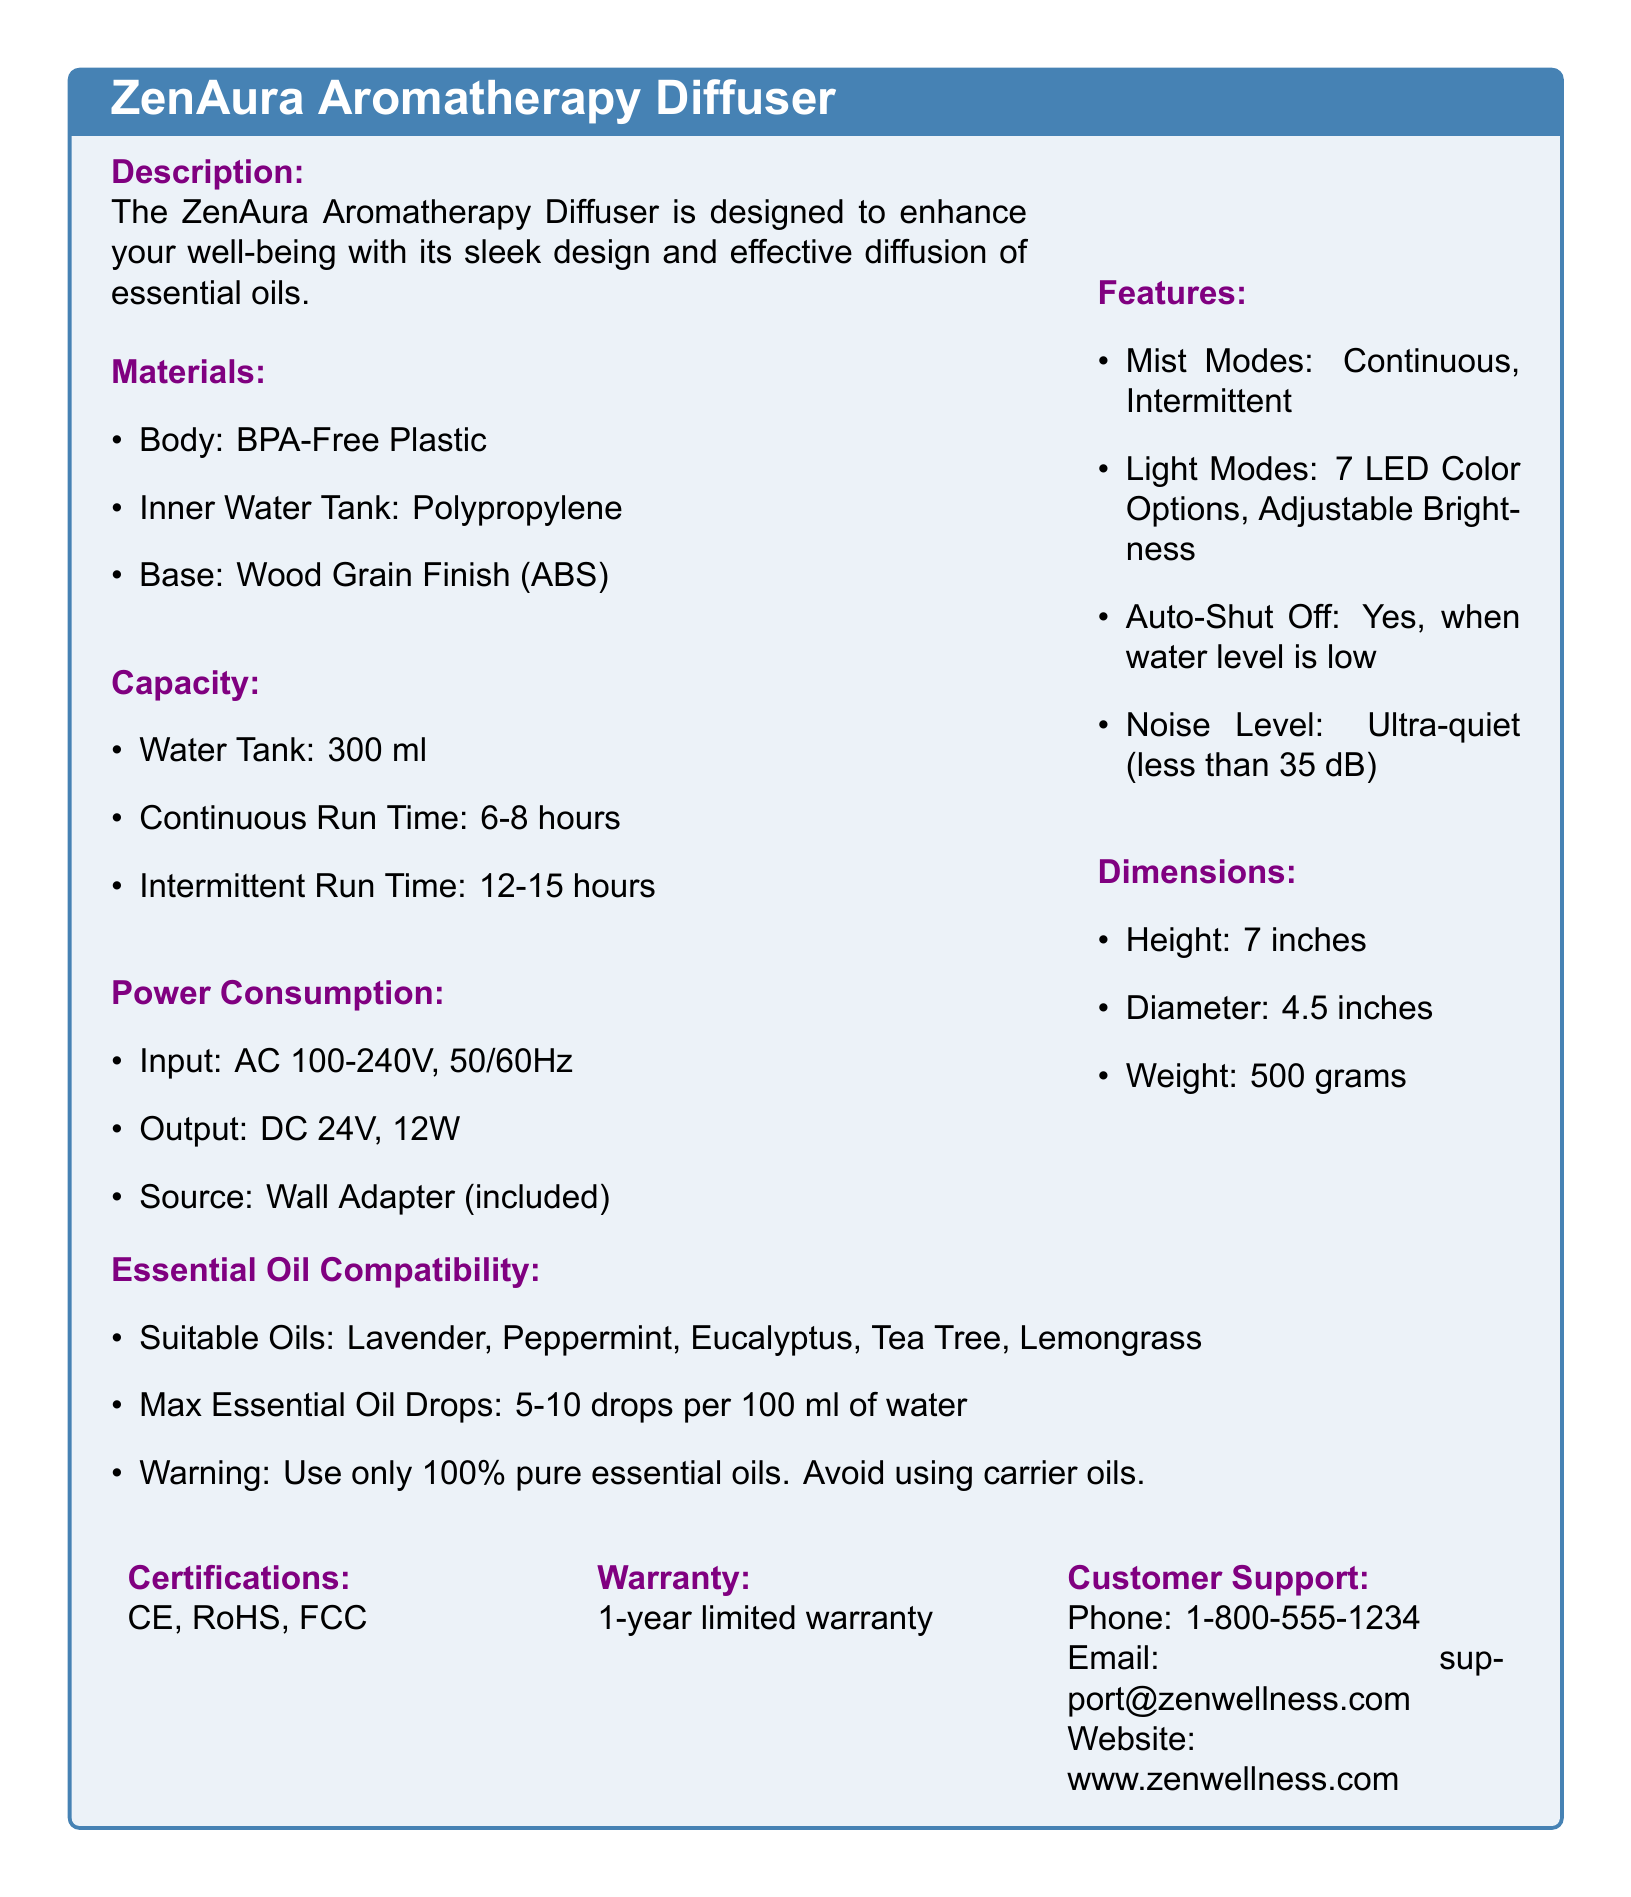What is the body material of the diffuser? The body material is specified as BPA-Free Plastic in the document.
Answer: BPA-Free Plastic What is the water tank capacity? The water tank capacity is listed as 300 ml in the specification sheet.
Answer: 300 ml What is the continuous run time of the diffuser? The continuous run time is mentioned as 6-8 hours in the document.
Answer: 6-8 hours How many LED color options does the diffuser have? The document states that there are 7 LED color options available for the diffuser.
Answer: 7 What is the noise level of the diffuser? The noise level is indicated to be ultra-quiet (less than 35 dB) in the specifications.
Answer: less than 35 dB What is the power output of the diffuser? The power output is specified as DC 24V, 12W in the document.
Answer: DC 24V, 12W What types of essential oils are compatible? The compatible essential oils mentioned include Lavender, Peppermint, Eucalyptus, Tea Tree, and Lemongrass.
Answer: Lavender, Peppermint, Eucalyptus, Tea Tree, Lemongrass Is there an auto-shut off feature? The document confirms that there is an auto-shut off feature when the water level is low.
Answer: Yes What is the warranty period for the diffuser? The warranty period is stated as a 1-year limited warranty in the specification sheet.
Answer: 1-year limited warranty 